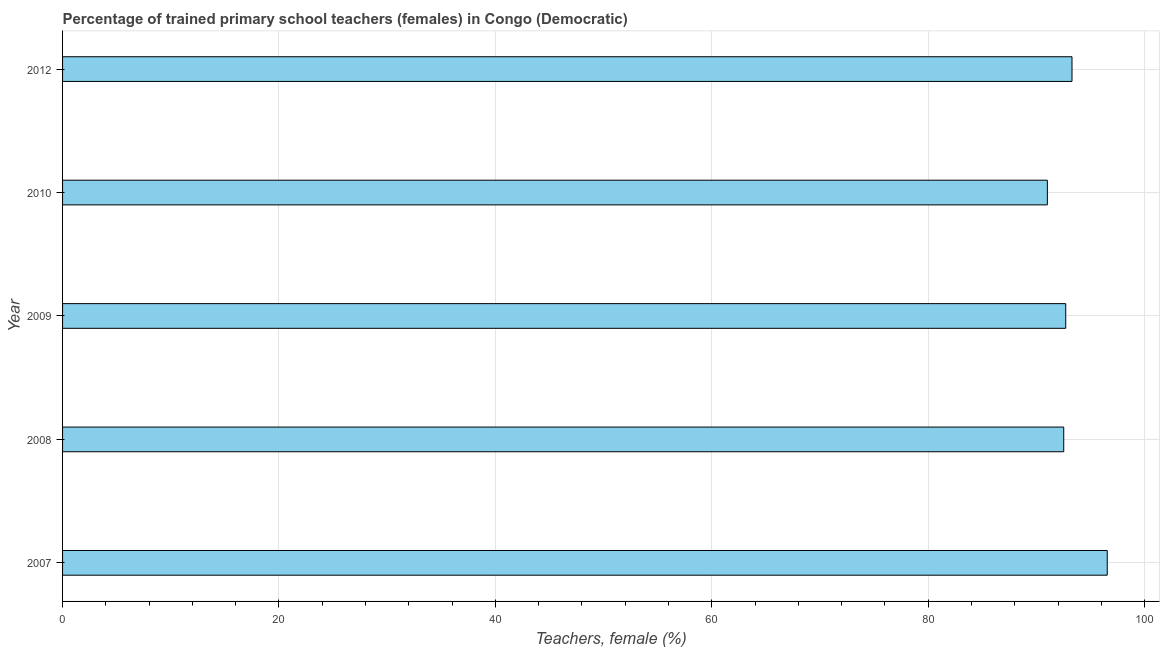What is the title of the graph?
Offer a terse response. Percentage of trained primary school teachers (females) in Congo (Democratic). What is the label or title of the X-axis?
Make the answer very short. Teachers, female (%). What is the percentage of trained female teachers in 2007?
Give a very brief answer. 96.54. Across all years, what is the maximum percentage of trained female teachers?
Offer a very short reply. 96.54. Across all years, what is the minimum percentage of trained female teachers?
Offer a very short reply. 91.01. In which year was the percentage of trained female teachers maximum?
Keep it short and to the point. 2007. In which year was the percentage of trained female teachers minimum?
Provide a succinct answer. 2010. What is the sum of the percentage of trained female teachers?
Offer a very short reply. 466.07. What is the difference between the percentage of trained female teachers in 2009 and 2010?
Your answer should be compact. 1.7. What is the average percentage of trained female teachers per year?
Offer a very short reply. 93.21. What is the median percentage of trained female teachers?
Ensure brevity in your answer.  92.71. In how many years, is the percentage of trained female teachers greater than 88 %?
Keep it short and to the point. 5. Do a majority of the years between 2009 and 2007 (inclusive) have percentage of trained female teachers greater than 12 %?
Give a very brief answer. Yes. Is the percentage of trained female teachers in 2009 less than that in 2010?
Make the answer very short. No. Is the difference between the percentage of trained female teachers in 2007 and 2012 greater than the difference between any two years?
Your answer should be very brief. No. What is the difference between the highest and the second highest percentage of trained female teachers?
Make the answer very short. 3.26. What is the difference between the highest and the lowest percentage of trained female teachers?
Keep it short and to the point. 5.54. In how many years, is the percentage of trained female teachers greater than the average percentage of trained female teachers taken over all years?
Your answer should be compact. 2. How many bars are there?
Make the answer very short. 5. Are the values on the major ticks of X-axis written in scientific E-notation?
Your answer should be compact. No. What is the Teachers, female (%) in 2007?
Offer a terse response. 96.54. What is the Teachers, female (%) of 2008?
Provide a short and direct response. 92.52. What is the Teachers, female (%) of 2009?
Offer a terse response. 92.71. What is the Teachers, female (%) in 2010?
Provide a succinct answer. 91.01. What is the Teachers, female (%) in 2012?
Offer a very short reply. 93.29. What is the difference between the Teachers, female (%) in 2007 and 2008?
Give a very brief answer. 4.02. What is the difference between the Teachers, female (%) in 2007 and 2009?
Your answer should be very brief. 3.84. What is the difference between the Teachers, female (%) in 2007 and 2010?
Your response must be concise. 5.54. What is the difference between the Teachers, female (%) in 2007 and 2012?
Keep it short and to the point. 3.26. What is the difference between the Teachers, female (%) in 2008 and 2009?
Offer a terse response. -0.18. What is the difference between the Teachers, female (%) in 2008 and 2010?
Provide a succinct answer. 1.51. What is the difference between the Teachers, female (%) in 2008 and 2012?
Offer a terse response. -0.76. What is the difference between the Teachers, female (%) in 2009 and 2010?
Ensure brevity in your answer.  1.7. What is the difference between the Teachers, female (%) in 2009 and 2012?
Keep it short and to the point. -0.58. What is the difference between the Teachers, female (%) in 2010 and 2012?
Offer a terse response. -2.28. What is the ratio of the Teachers, female (%) in 2007 to that in 2008?
Give a very brief answer. 1.04. What is the ratio of the Teachers, female (%) in 2007 to that in 2009?
Give a very brief answer. 1.04. What is the ratio of the Teachers, female (%) in 2007 to that in 2010?
Give a very brief answer. 1.06. What is the ratio of the Teachers, female (%) in 2007 to that in 2012?
Offer a terse response. 1.03. What is the ratio of the Teachers, female (%) in 2008 to that in 2010?
Provide a short and direct response. 1.02. What is the ratio of the Teachers, female (%) in 2009 to that in 2010?
Your response must be concise. 1.02. 